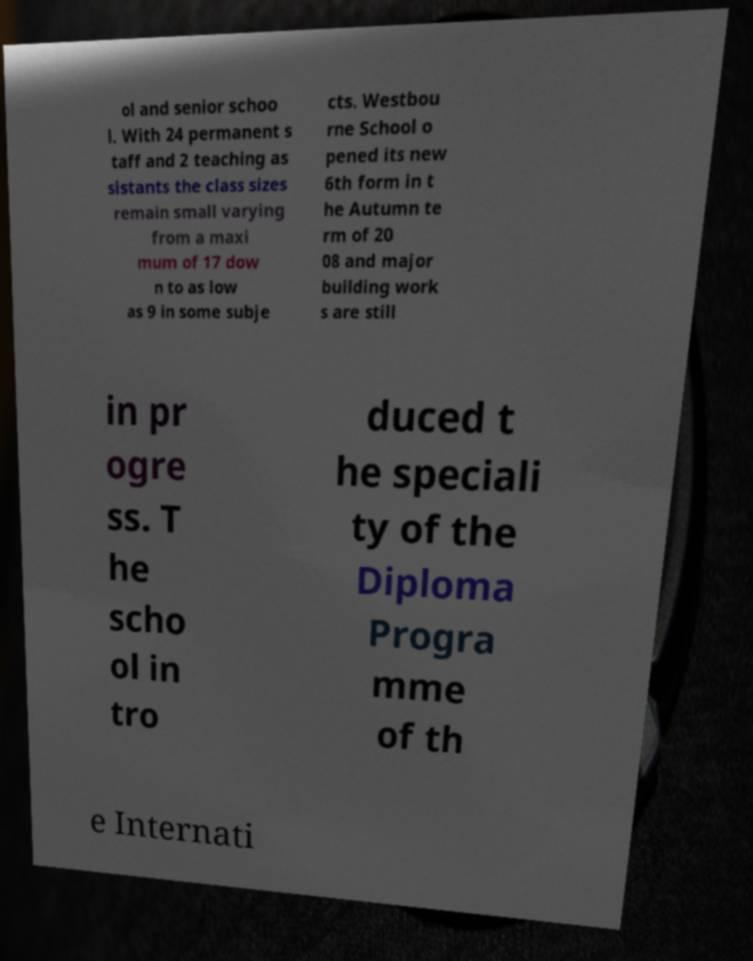I need the written content from this picture converted into text. Can you do that? ol and senior schoo l. With 24 permanent s taff and 2 teaching as sistants the class sizes remain small varying from a maxi mum of 17 dow n to as low as 9 in some subje cts. Westbou rne School o pened its new 6th form in t he Autumn te rm of 20 08 and major building work s are still in pr ogre ss. T he scho ol in tro duced t he speciali ty of the Diploma Progra mme of th e Internati 